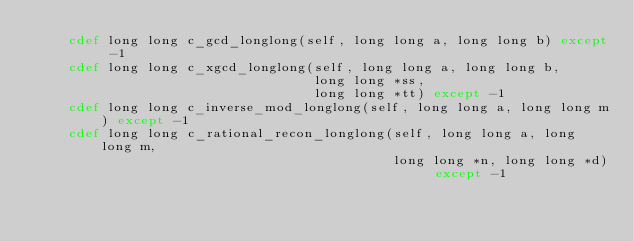Convert code to text. <code><loc_0><loc_0><loc_500><loc_500><_Cython_>    cdef long long c_gcd_longlong(self, long long a, long long b) except -1
    cdef long long c_xgcd_longlong(self, long long a, long long b,
                                   long long *ss,
                                   long long *tt) except -1
    cdef long long c_inverse_mod_longlong(self, long long a, long long m) except -1
    cdef long long c_rational_recon_longlong(self, long long a, long long m,
                                             long long *n, long long *d) except -1
</code> 